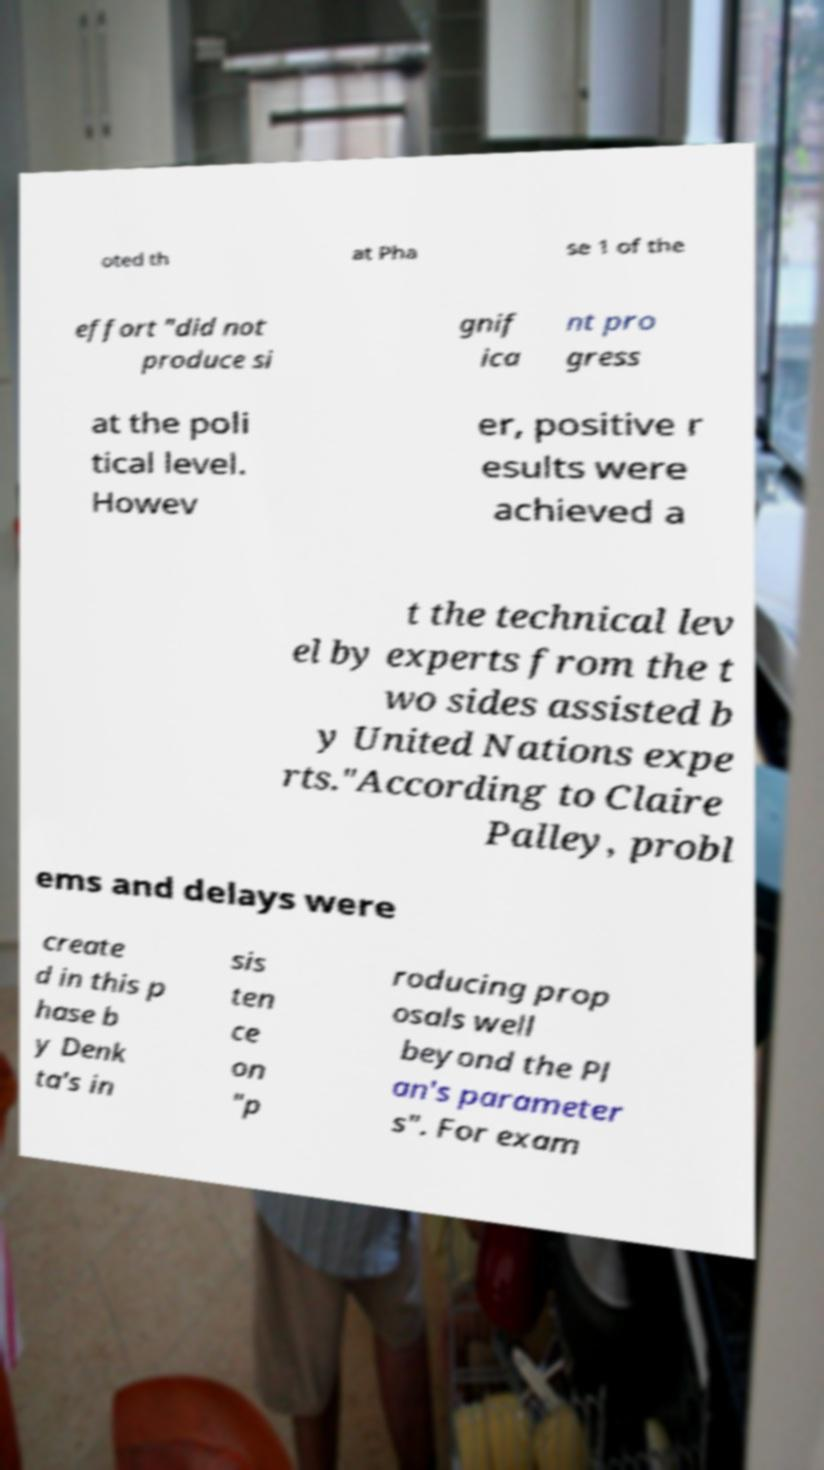Can you read and provide the text displayed in the image?This photo seems to have some interesting text. Can you extract and type it out for me? oted th at Pha se 1 of the effort "did not produce si gnif ica nt pro gress at the poli tical level. Howev er, positive r esults were achieved a t the technical lev el by experts from the t wo sides assisted b y United Nations expe rts."According to Claire Palley, probl ems and delays were create d in this p hase b y Denk ta's in sis ten ce on "p roducing prop osals well beyond the Pl an's parameter s". For exam 